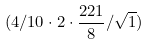Convert formula to latex. <formula><loc_0><loc_0><loc_500><loc_500>( 4 / 1 0 \cdot 2 \cdot \frac { 2 2 1 } { 8 } / \sqrt { 1 } )</formula> 